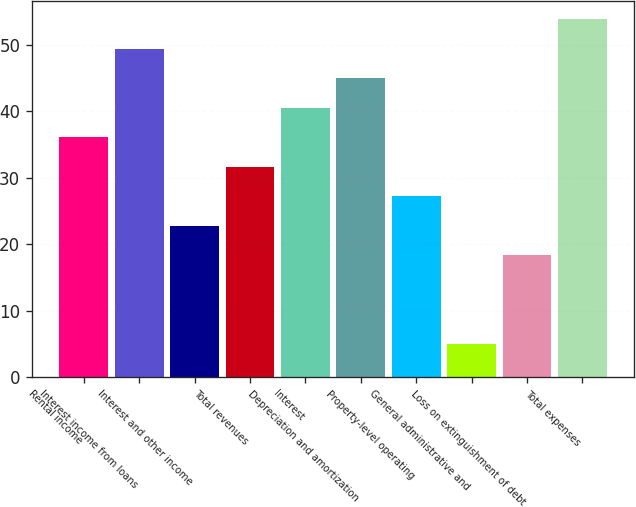<chart> <loc_0><loc_0><loc_500><loc_500><bar_chart><fcel>Rental income<fcel>Interest income from loans<fcel>Interest and other income<fcel>Total revenues<fcel>Interest<fcel>Depreciation and amortization<fcel>Property-level operating<fcel>General administrative and<fcel>Loss on extinguishment of debt<fcel>Total expenses<nl><fcel>36.12<fcel>49.44<fcel>22.8<fcel>31.68<fcel>40.56<fcel>45<fcel>27.24<fcel>5.04<fcel>18.36<fcel>53.88<nl></chart> 